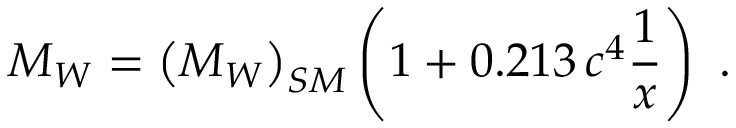<formula> <loc_0><loc_0><loc_500><loc_500>M _ { W } = \left ( M _ { W } \right ) _ { S M } \left ( 1 + 0 . 2 1 3 \, c ^ { 4 } { \frac { 1 } { x } } \right ) .</formula> 